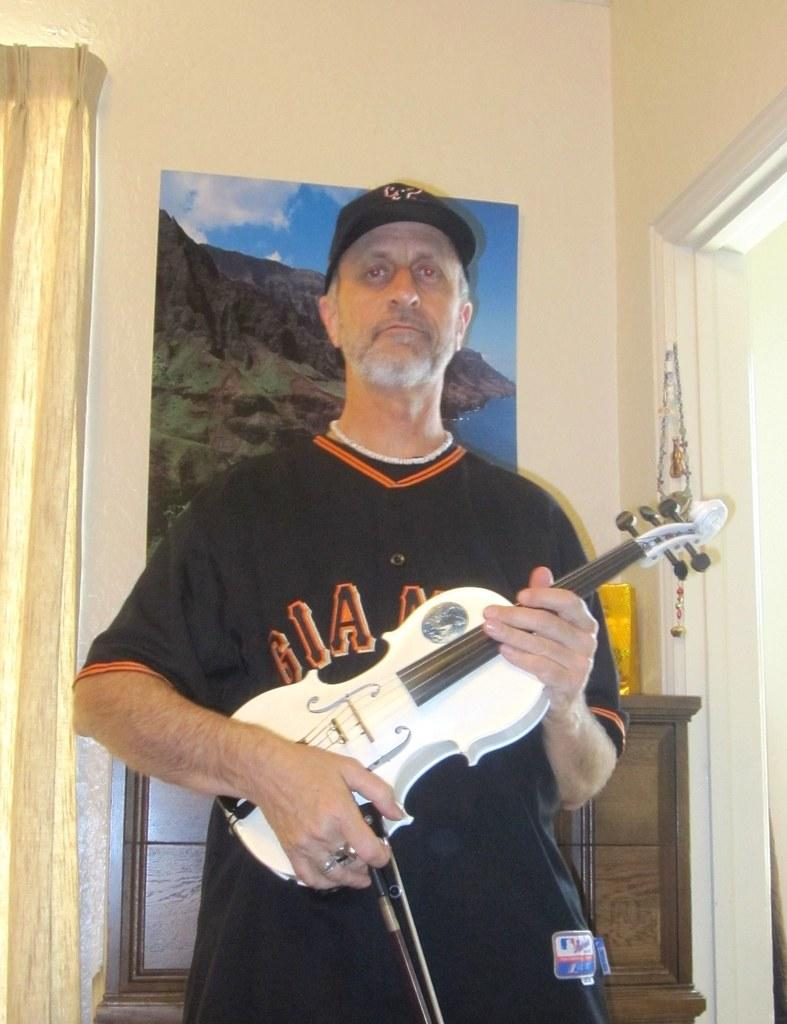What is the person in the image doing? The person is playing a violin. What is the person wearing on their upper body? The person is wearing a black T-shirt. What type of headwear is the person wearing? The person is wearing a cap. What can be seen in the background of the image? There is a scenery in the background of the image. How is the scenery displayed in the image? The scenery is attached to a wall. What type of drug is the person using to enhance their violin playing in the image? There is no indication of any drug use in the image; the person is simply playing the violin. What design elements can be seen on the violin in the image? The image does not provide enough detail to describe any design elements on the violin. 